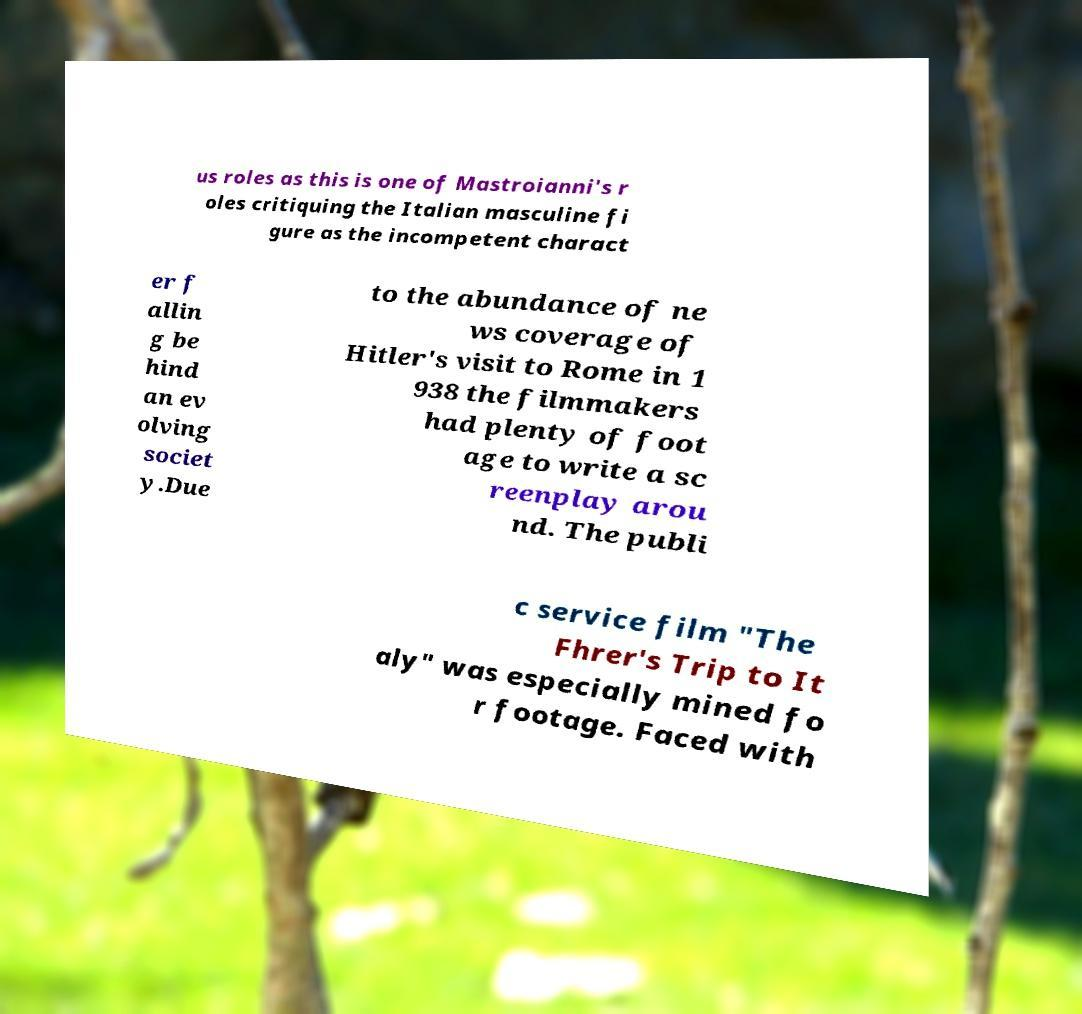I need the written content from this picture converted into text. Can you do that? us roles as this is one of Mastroianni's r oles critiquing the Italian masculine fi gure as the incompetent charact er f allin g be hind an ev olving societ y.Due to the abundance of ne ws coverage of Hitler's visit to Rome in 1 938 the filmmakers had plenty of foot age to write a sc reenplay arou nd. The publi c service film "The Fhrer's Trip to It aly" was especially mined fo r footage. Faced with 